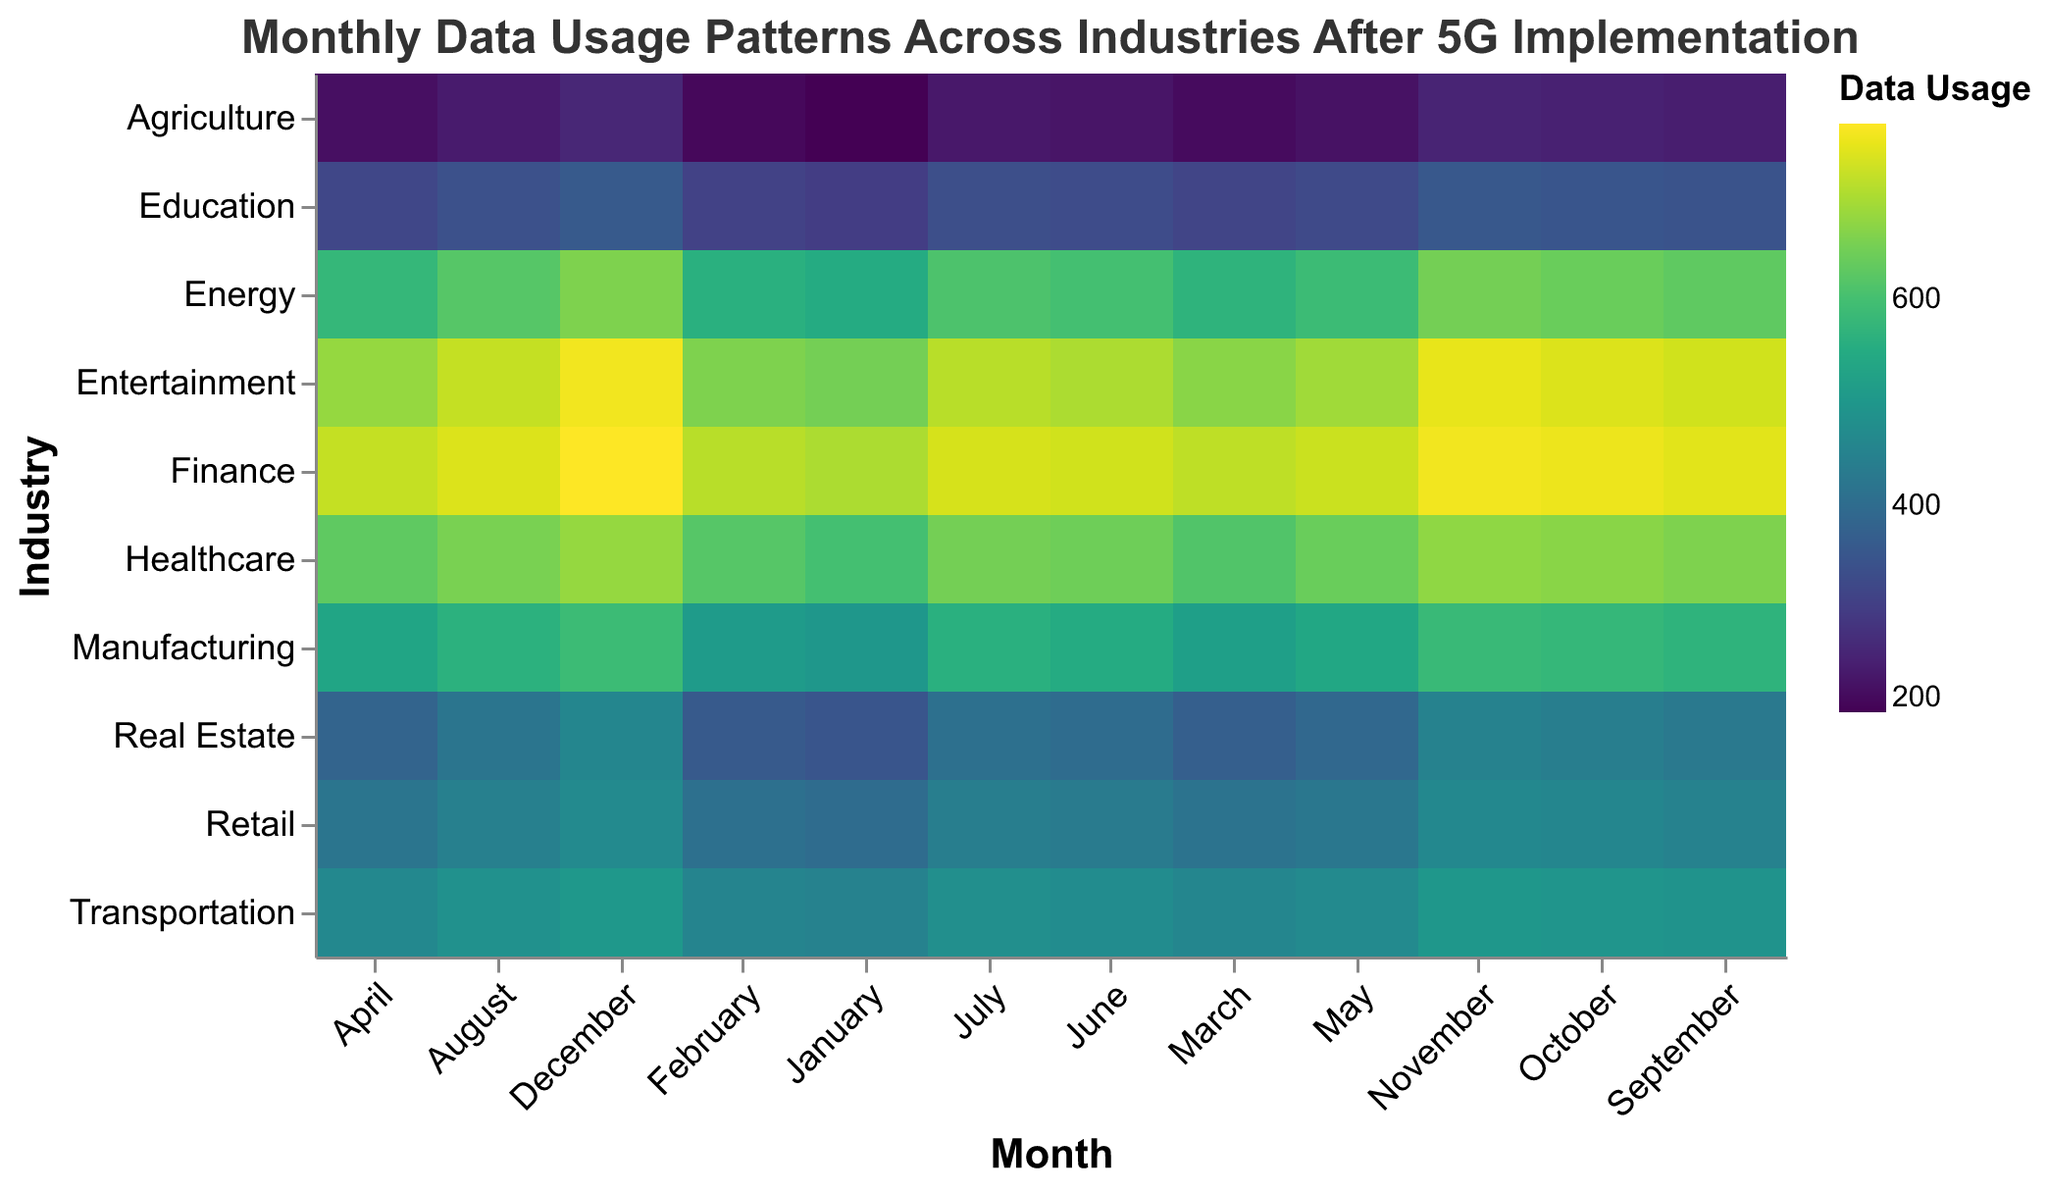What industry had the highest data usage in December? Looking at the December column, the "Finance" industry has the highest data usage value of 770.
Answer: Finance How does the data usage pattern in the Retail industry change from January to December? Observing the Retail industry's row, the data usage starts at 400 in January and progressively increments month by month to reach 470 in December.
Answer: Increases steadily Which industry has the largest increase in data usage from January to December? To find the largest increase, subtract the January usage from December usage for all industries. Finance has a jump from 700 to 770, yielding a 70 increase, which is the largest among all industries.
Answer: Finance Compare the data usage in August for Healthcare and Entertainment. Which is higher? In August, Healthcare has a usage of 655, while Entertainment has a usage of 720. Therefore, Entertainment's data usage is higher.
Answer: Entertainment What is the average data usage of the Energy industry for the first quarter (January, February, March)? Add January, February, and March usages for the Energy industry (550 + 560 + 570 = 1680) and divide by 3. The average is 1680 / 3 = 560.
Answer: 560 Which month had the highest average data usage across all industries? Calculate the average for each month by summing the data for all industries and dividing by the number of industries. October has the highest total summing all industries (6275) giving an average of approximately 627.5.
Answer: October What is the total data usage for the Healthcare industry throughout the year? Sum the data usage for Healthcare from January to December. (600 + 620 + 615 + 630 + 640 + 645 + 650 + 655 + 660 + 670 + 675 + 680 = 7740)
Answer: 7740 Which industry has the least variation in data usage throughout the year? Calculate the range (max - min) of data usage for each industry. The Agriculture industry has the least variation with a difference of 60 (260 - 200).
Answer: Agriculture 